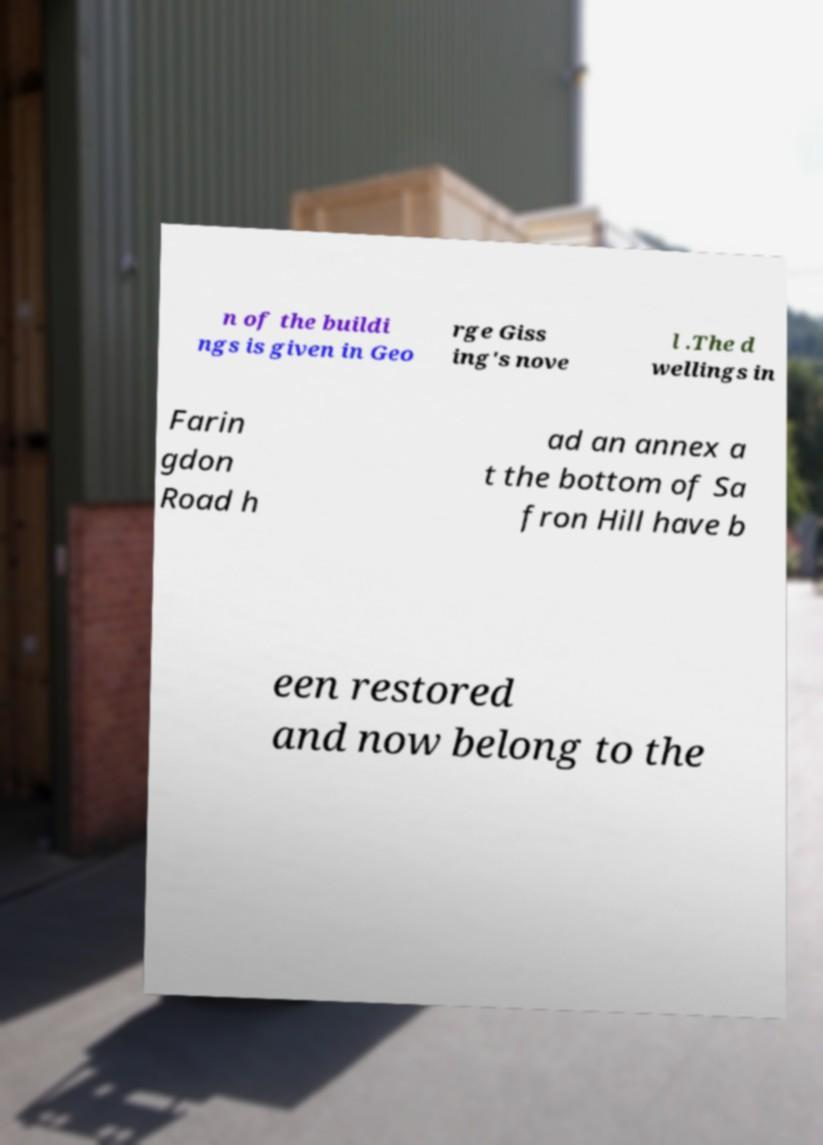Could you extract and type out the text from this image? n of the buildi ngs is given in Geo rge Giss ing's nove l .The d wellings in Farin gdon Road h ad an annex a t the bottom of Sa fron Hill have b een restored and now belong to the 